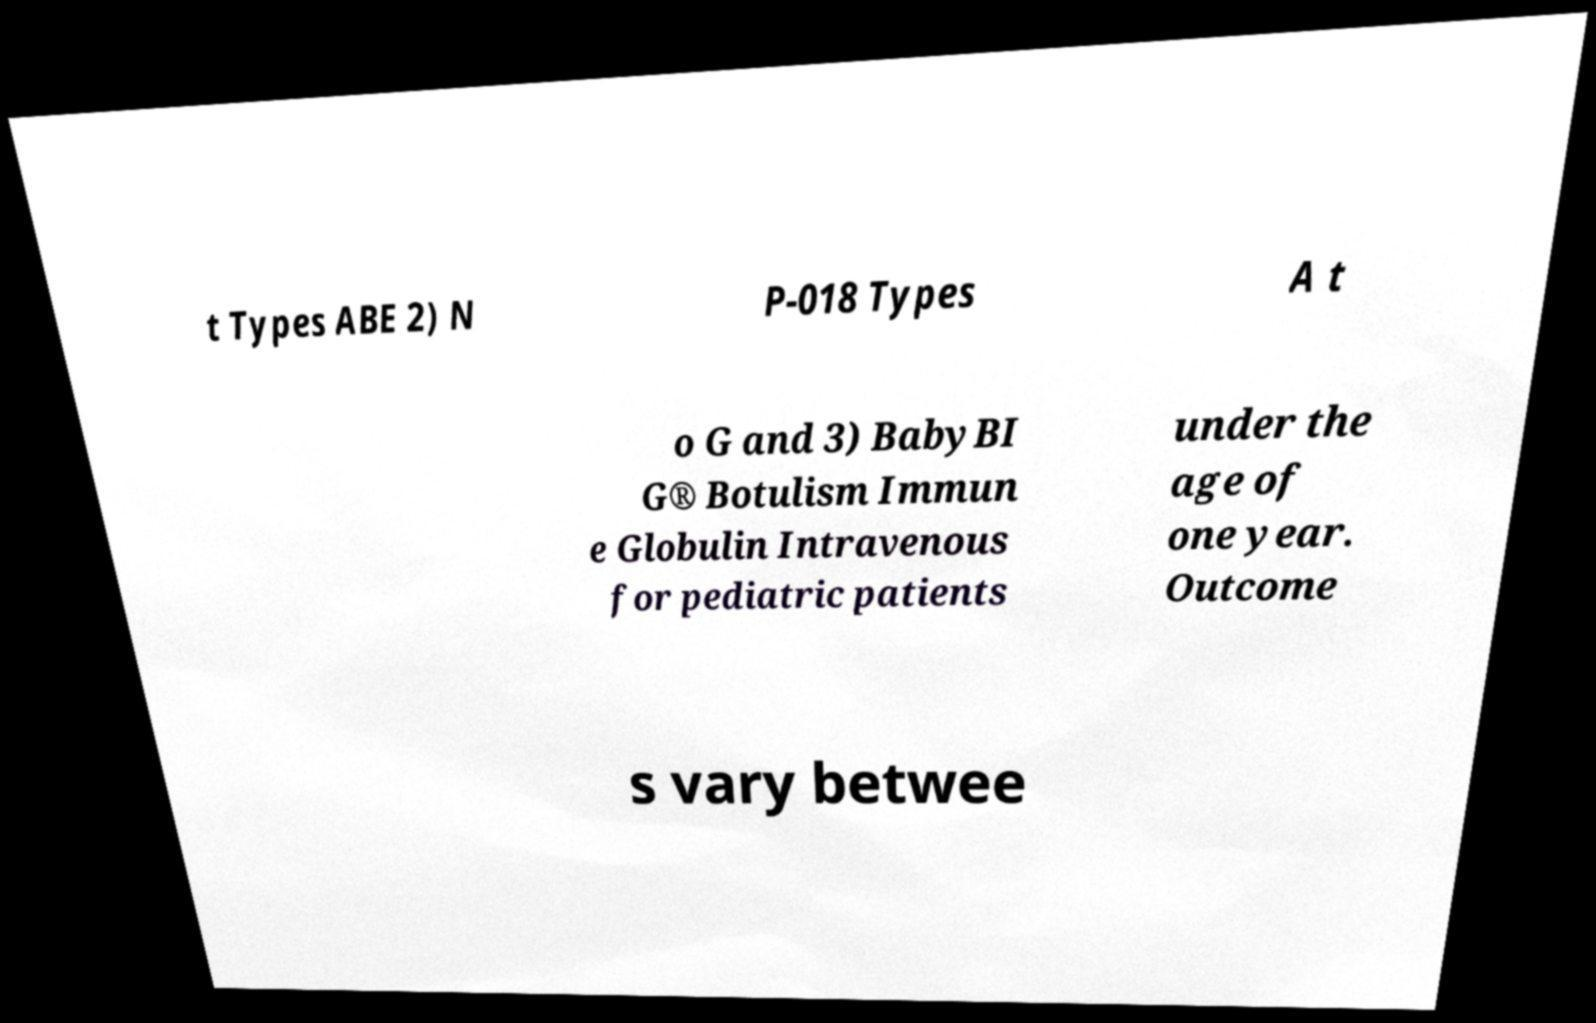Please identify and transcribe the text found in this image. t Types ABE 2) N P-018 Types A t o G and 3) BabyBI G® Botulism Immun e Globulin Intravenous for pediatric patients under the age of one year. Outcome s vary betwee 